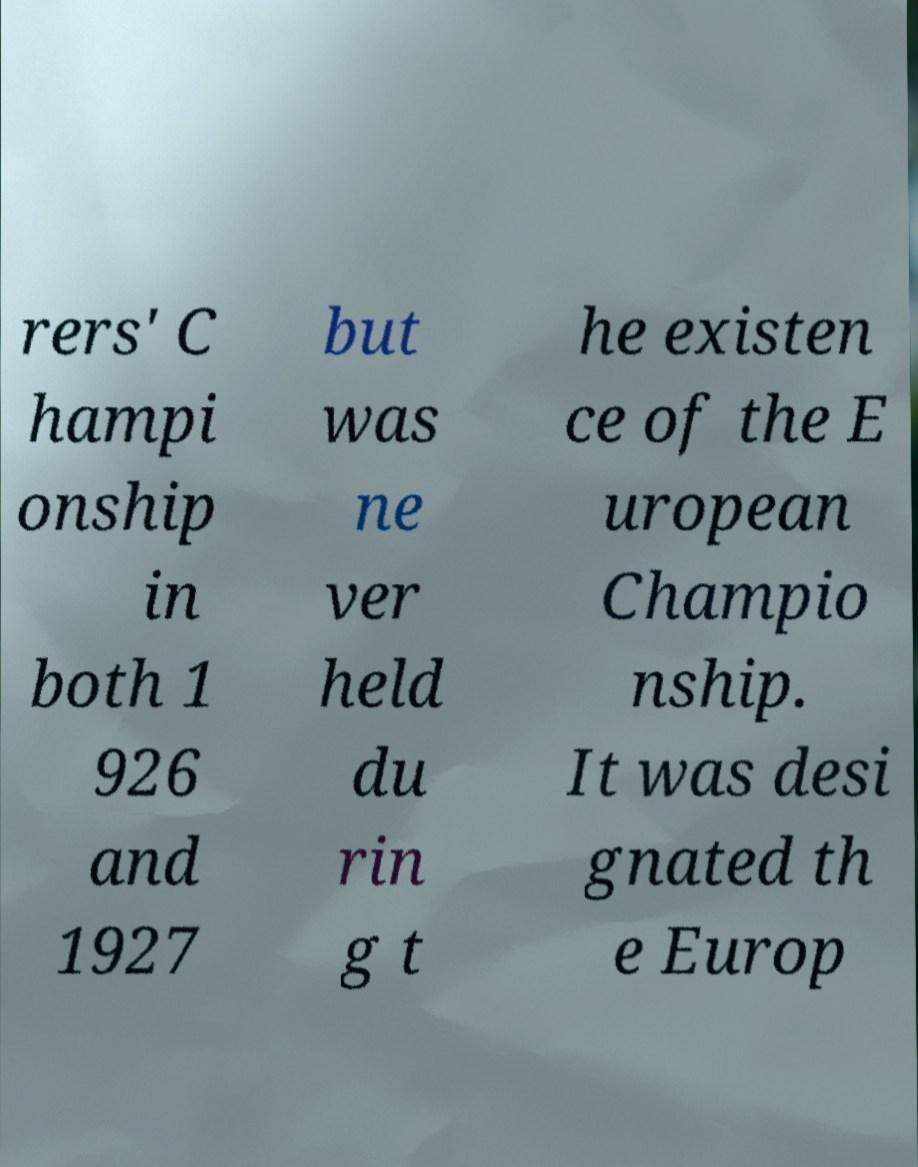Can you accurately transcribe the text from the provided image for me? rers' C hampi onship in both 1 926 and 1927 but was ne ver held du rin g t he existen ce of the E uropean Champio nship. It was desi gnated th e Europ 